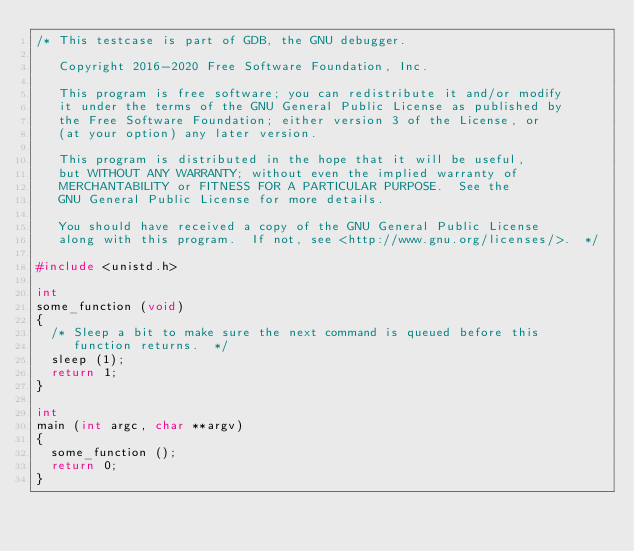Convert code to text. <code><loc_0><loc_0><loc_500><loc_500><_C_>/* This testcase is part of GDB, the GNU debugger.

   Copyright 2016-2020 Free Software Foundation, Inc.

   This program is free software; you can redistribute it and/or modify
   it under the terms of the GNU General Public License as published by
   the Free Software Foundation; either version 3 of the License, or
   (at your option) any later version.

   This program is distributed in the hope that it will be useful,
   but WITHOUT ANY WARRANTY; without even the implied warranty of
   MERCHANTABILITY or FITNESS FOR A PARTICULAR PURPOSE.  See the
   GNU General Public License for more details.

   You should have received a copy of the GNU General Public License
   along with this program.  If not, see <http://www.gnu.org/licenses/>.  */

#include <unistd.h>

int
some_function (void)
{
  /* Sleep a bit to make sure the next command is queued before this
     function returns.  */
  sleep (1);
  return 1;
}

int
main (int argc, char **argv)
{
  some_function ();
  return 0;
}
</code> 